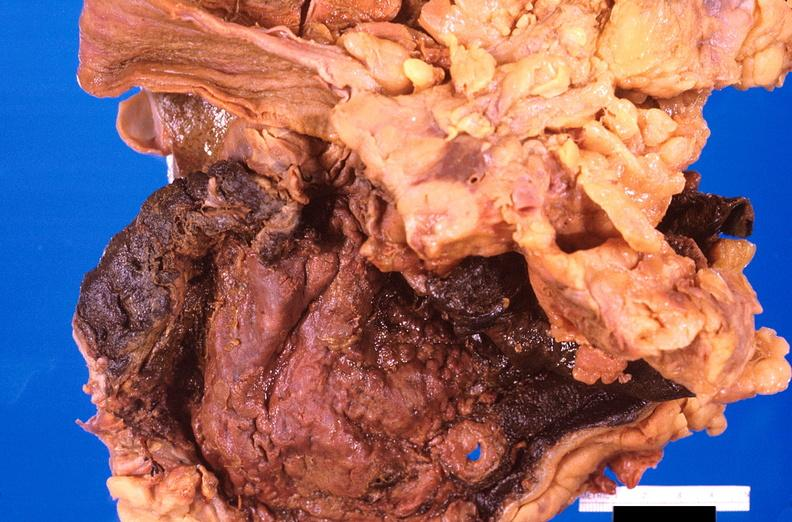where does this belong to?
Answer the question using a single word or phrase. Gastrointestinal system 